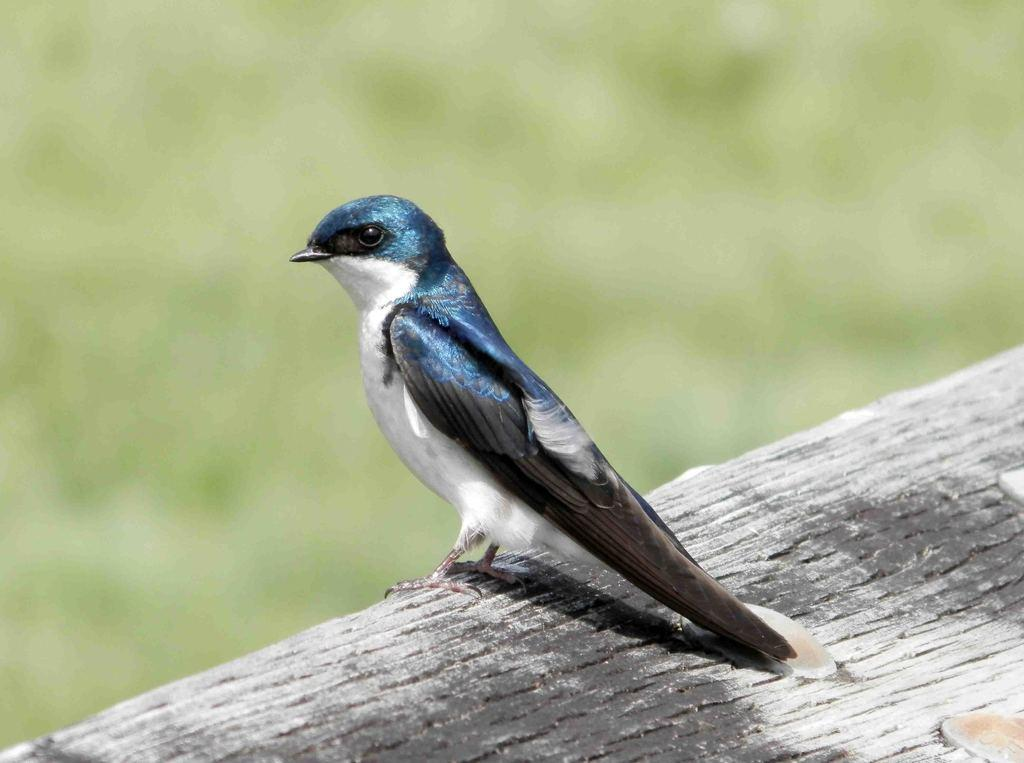What type of animal is in the image? There is a bird in the image. What is the bird sitting on? The bird is on a wooden surface. What colors can be seen on the bird? The bird has blue, black, and white colors. How would you describe the background of the image? The background of the image is blurred. Is there a crowd of people gathered around the bird in the image? No, there is no crowd of people present in the image. 